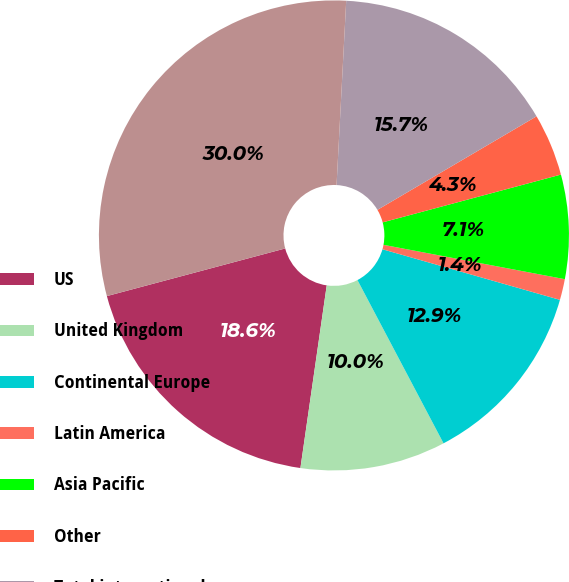Convert chart to OTSL. <chart><loc_0><loc_0><loc_500><loc_500><pie_chart><fcel>US<fcel>United Kingdom<fcel>Continental Europe<fcel>Latin America<fcel>Asia Pacific<fcel>Other<fcel>Total international<fcel>Total consolidated<nl><fcel>18.57%<fcel>10.0%<fcel>12.86%<fcel>1.44%<fcel>7.15%<fcel>4.29%<fcel>15.71%<fcel>29.99%<nl></chart> 